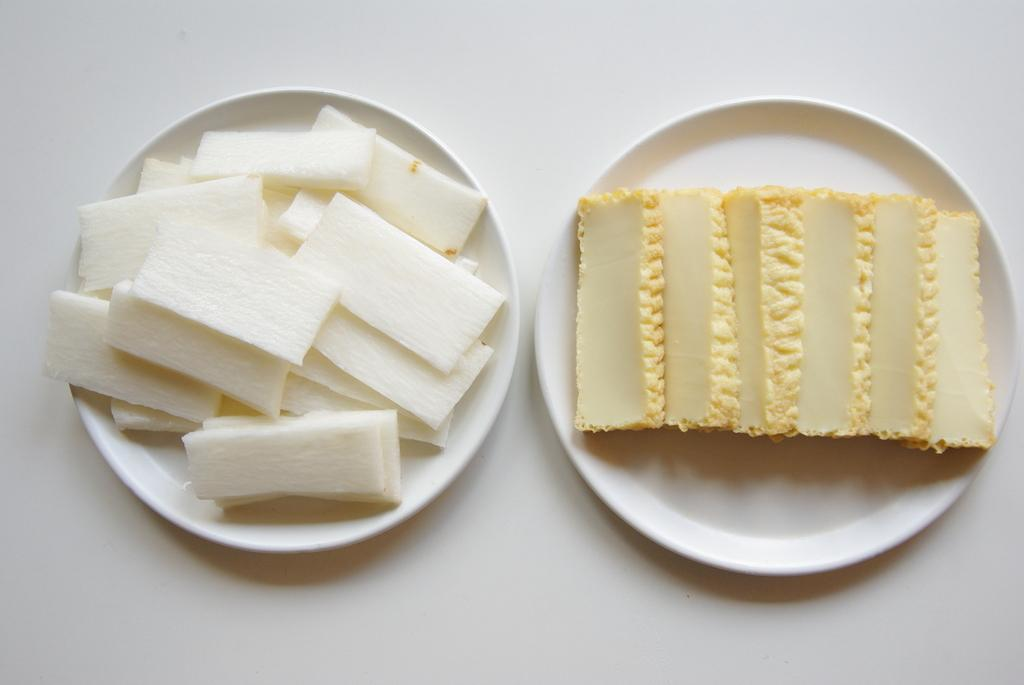What is present on the plates in the image? There is food in plates in the image. Can you describe the type of food on the plates? The provided facts do not specify the type of food on the plates. How many plates with food can be seen in the image? The provided facts do not specify the number of plates with food. What type of sugar is being used to slow down the car in the image? There is no car or sugar present in the image; it only features food on plates. 